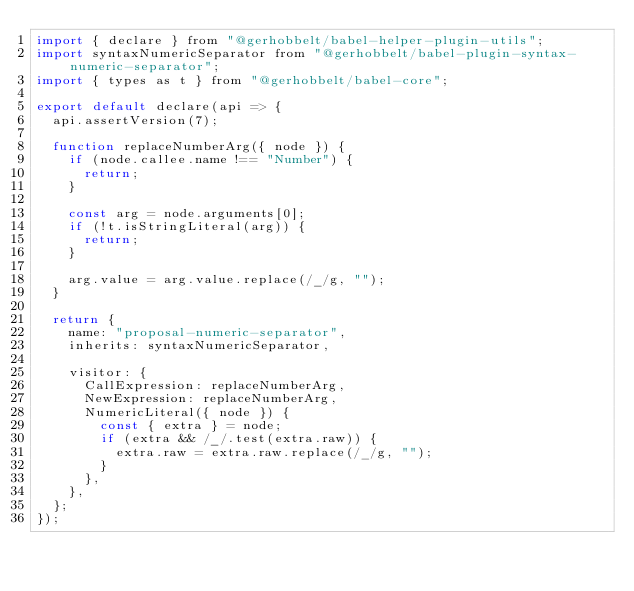Convert code to text. <code><loc_0><loc_0><loc_500><loc_500><_JavaScript_>import { declare } from "@gerhobbelt/babel-helper-plugin-utils";
import syntaxNumericSeparator from "@gerhobbelt/babel-plugin-syntax-numeric-separator";
import { types as t } from "@gerhobbelt/babel-core";

export default declare(api => {
  api.assertVersion(7);

  function replaceNumberArg({ node }) {
    if (node.callee.name !== "Number") {
      return;
    }

    const arg = node.arguments[0];
    if (!t.isStringLiteral(arg)) {
      return;
    }

    arg.value = arg.value.replace(/_/g, "");
  }

  return {
    name: "proposal-numeric-separator",
    inherits: syntaxNumericSeparator,

    visitor: {
      CallExpression: replaceNumberArg,
      NewExpression: replaceNumberArg,
      NumericLiteral({ node }) {
        const { extra } = node;
        if (extra && /_/.test(extra.raw)) {
          extra.raw = extra.raw.replace(/_/g, "");
        }
      },
    },
  };
});
</code> 